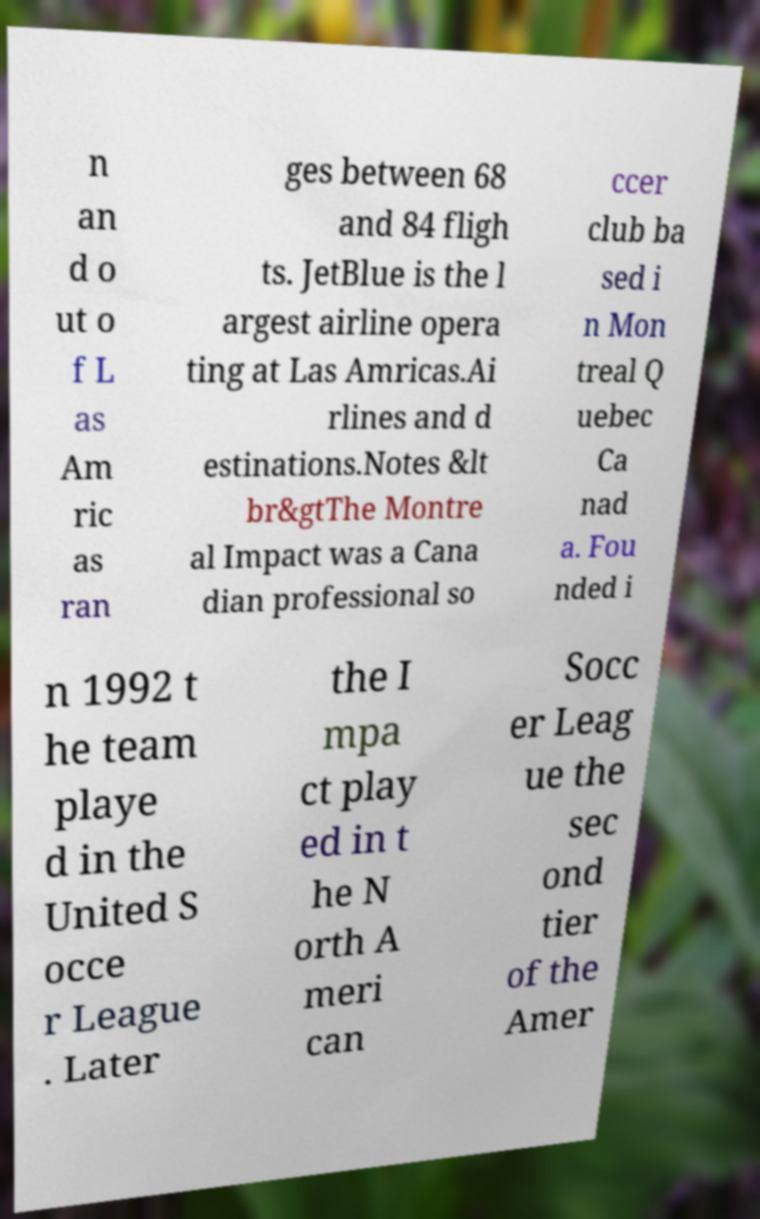Can you read and provide the text displayed in the image?This photo seems to have some interesting text. Can you extract and type it out for me? n an d o ut o f L as Am ric as ran ges between 68 and 84 fligh ts. JetBlue is the l argest airline opera ting at Las Amricas.Ai rlines and d estinations.Notes &lt br&gtThe Montre al Impact was a Cana dian professional so ccer club ba sed i n Mon treal Q uebec Ca nad a. Fou nded i n 1992 t he team playe d in the United S occe r League . Later the I mpa ct play ed in t he N orth A meri can Socc er Leag ue the sec ond tier of the Amer 